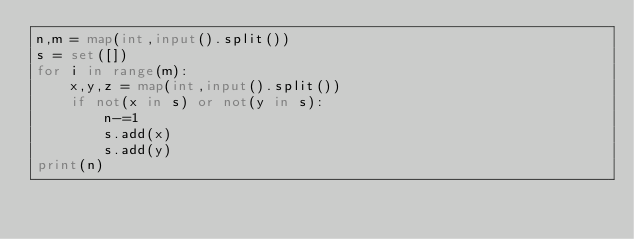<code> <loc_0><loc_0><loc_500><loc_500><_Python_>n,m = map(int,input().split())
s = set([])
for i in range(m):
    x,y,z = map(int,input().split())
    if not(x in s) or not(y in s):
        n-=1
        s.add(x)
        s.add(y)
print(n)</code> 